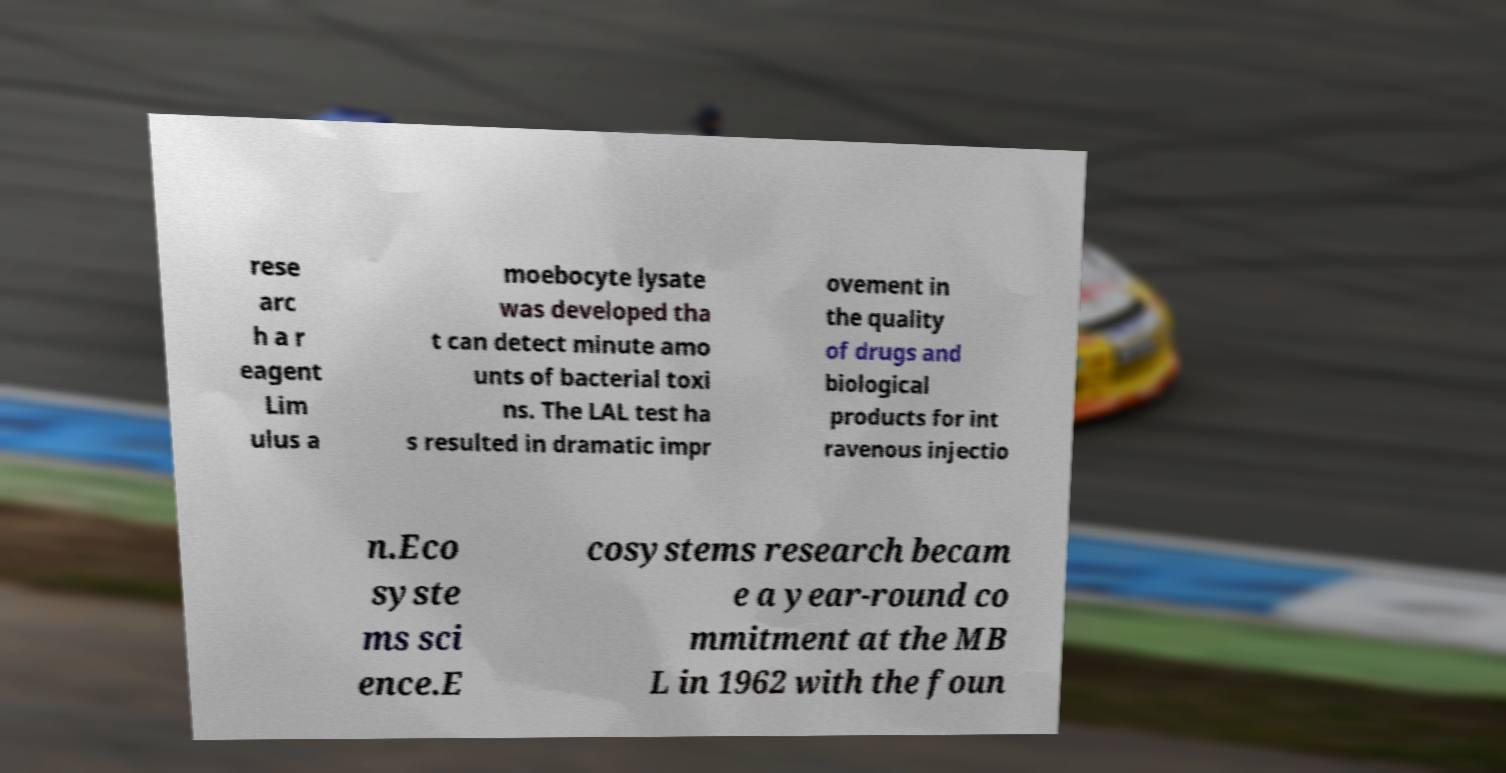I need the written content from this picture converted into text. Can you do that? rese arc h a r eagent Lim ulus a moebocyte lysate was developed tha t can detect minute amo unts of bacterial toxi ns. The LAL test ha s resulted in dramatic impr ovement in the quality of drugs and biological products for int ravenous injectio n.Eco syste ms sci ence.E cosystems research becam e a year-round co mmitment at the MB L in 1962 with the foun 